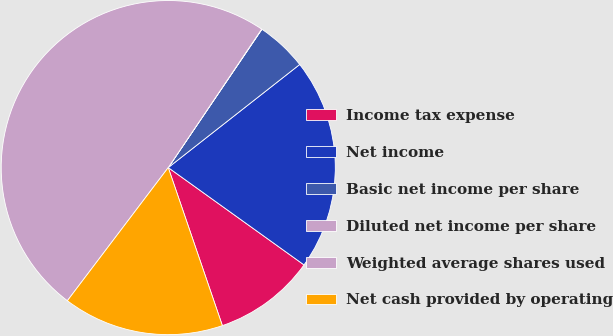Convert chart to OTSL. <chart><loc_0><loc_0><loc_500><loc_500><pie_chart><fcel>Income tax expense<fcel>Net income<fcel>Basic net income per share<fcel>Diluted net income per share<fcel>Weighted average shares used<fcel>Net cash provided by operating<nl><fcel>9.85%<fcel>20.48%<fcel>4.94%<fcel>0.03%<fcel>49.12%<fcel>15.57%<nl></chart> 